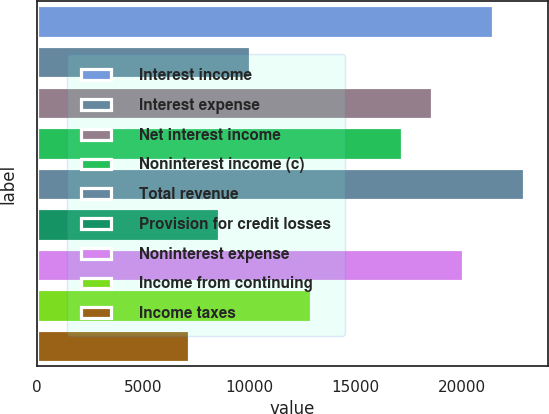Convert chart. <chart><loc_0><loc_0><loc_500><loc_500><bar_chart><fcel>Interest income<fcel>Interest expense<fcel>Net interest income<fcel>Noninterest income (c)<fcel>Total revenue<fcel>Provision for credit losses<fcel>Noninterest expense<fcel>Income from continuing<fcel>Income taxes<nl><fcel>21488.5<fcel>10028.6<fcel>18623.5<fcel>17191<fcel>22920.9<fcel>8596.07<fcel>20056<fcel>12893.5<fcel>7163.58<nl></chart> 